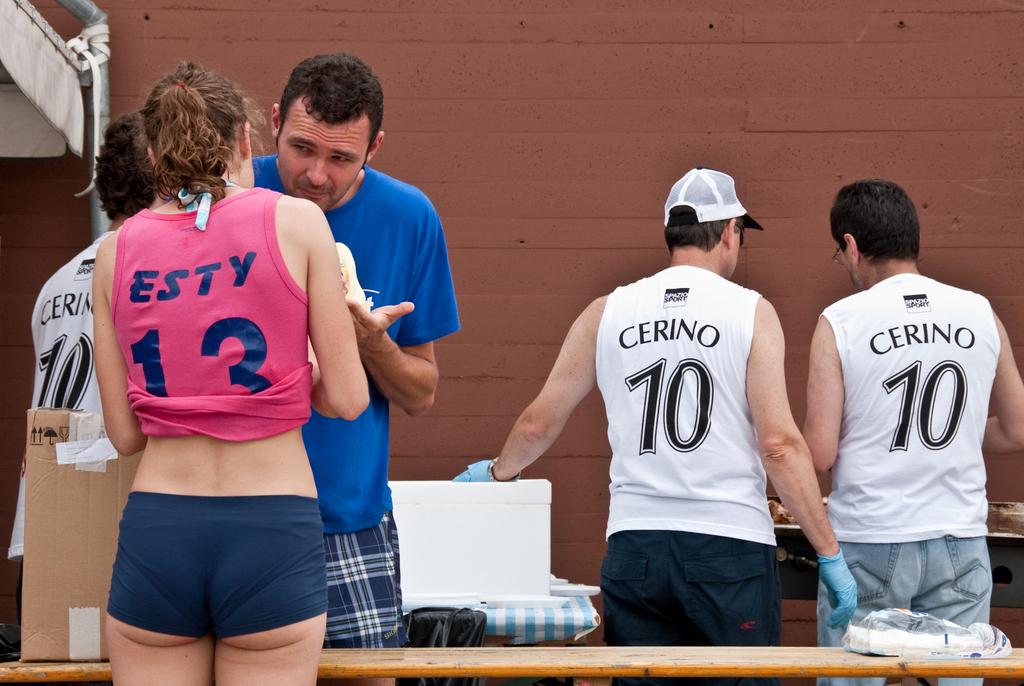What is the number on the white shirts?
Ensure brevity in your answer.  10. 